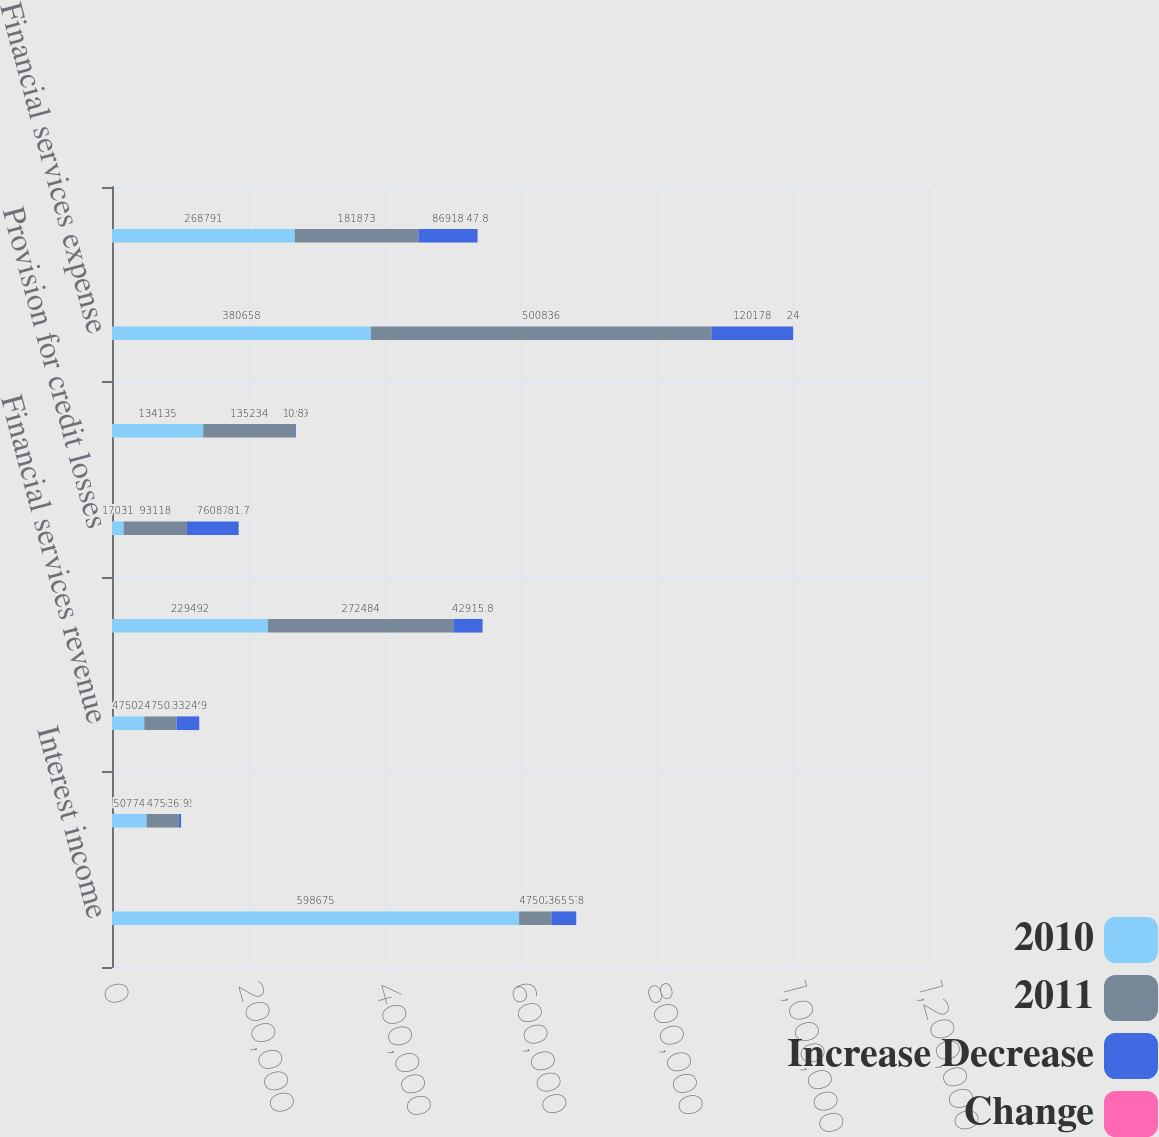<chart> <loc_0><loc_0><loc_500><loc_500><stacked_bar_chart><ecel><fcel>Interest income<fcel>Other income<fcel>Financial services revenue<fcel>Interest expense<fcel>Provision for credit losses<fcel>Operating expenses<fcel>Financial services expense<fcel>Operating income from<nl><fcel>2010<fcel>598675<fcel>50774<fcel>47502<fcel>229492<fcel>17031<fcel>134135<fcel>380658<fcel>268791<nl><fcel>2011<fcel>47502<fcel>47502<fcel>47502<fcel>272484<fcel>93118<fcel>135234<fcel>500836<fcel>181873<nl><fcel>Increase Decrease<fcel>36532<fcel>3272<fcel>33260<fcel>42992<fcel>76087<fcel>1099<fcel>120178<fcel>86918<nl><fcel>Change<fcel>5.8<fcel>6.9<fcel>4.9<fcel>15.8<fcel>81.7<fcel>0.8<fcel>24<fcel>47.8<nl></chart> 